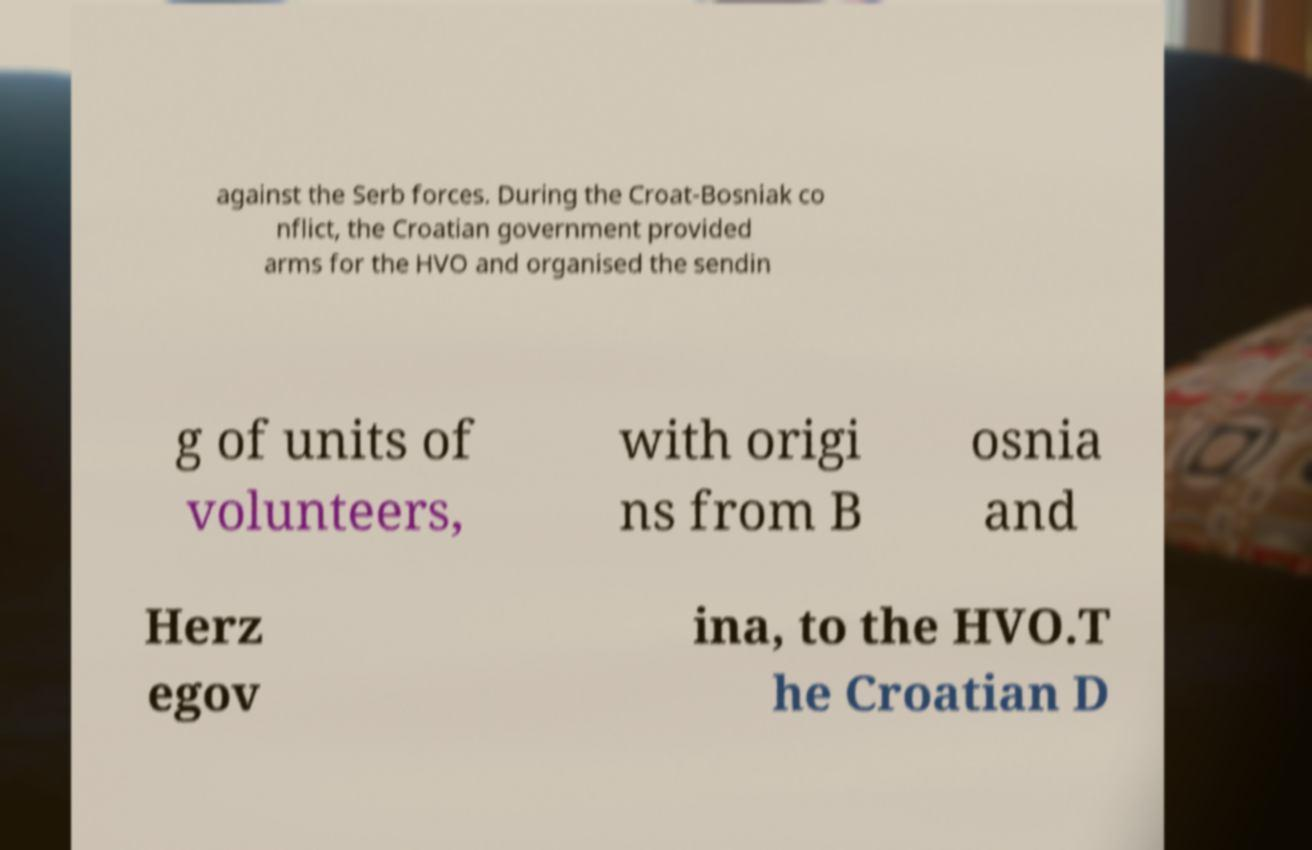Could you extract and type out the text from this image? against the Serb forces. During the Croat-Bosniak co nflict, the Croatian government provided arms for the HVO and organised the sendin g of units of volunteers, with origi ns from B osnia and Herz egov ina, to the HVO.T he Croatian D 